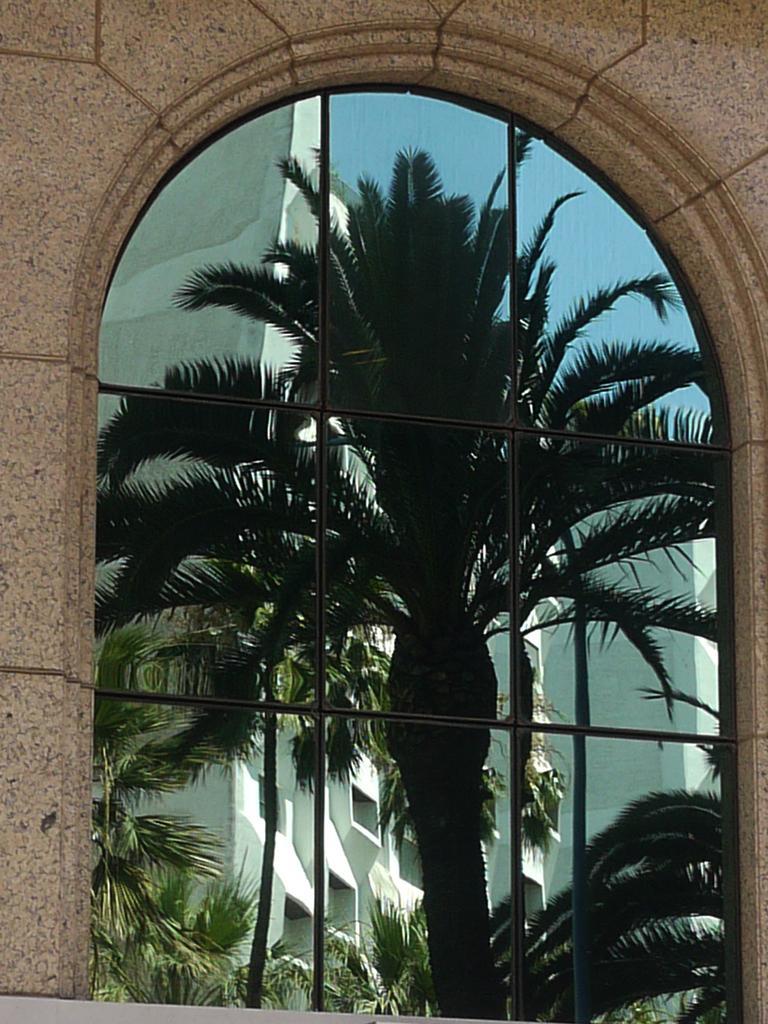Please provide a concise description of this image. In this picture I can see the glass in the middle, there is reflected image of trees, buildings and the sky. Around this glass there is the wall. 